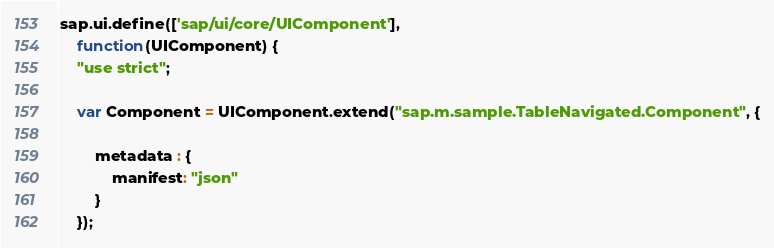Convert code to text. <code><loc_0><loc_0><loc_500><loc_500><_JavaScript_>sap.ui.define(['sap/ui/core/UIComponent'],
	function(UIComponent) {
	"use strict";

	var Component = UIComponent.extend("sap.m.sample.TableNavigated.Component", {

		metadata : {
			manifest: "json"
		}
	});
</code> 